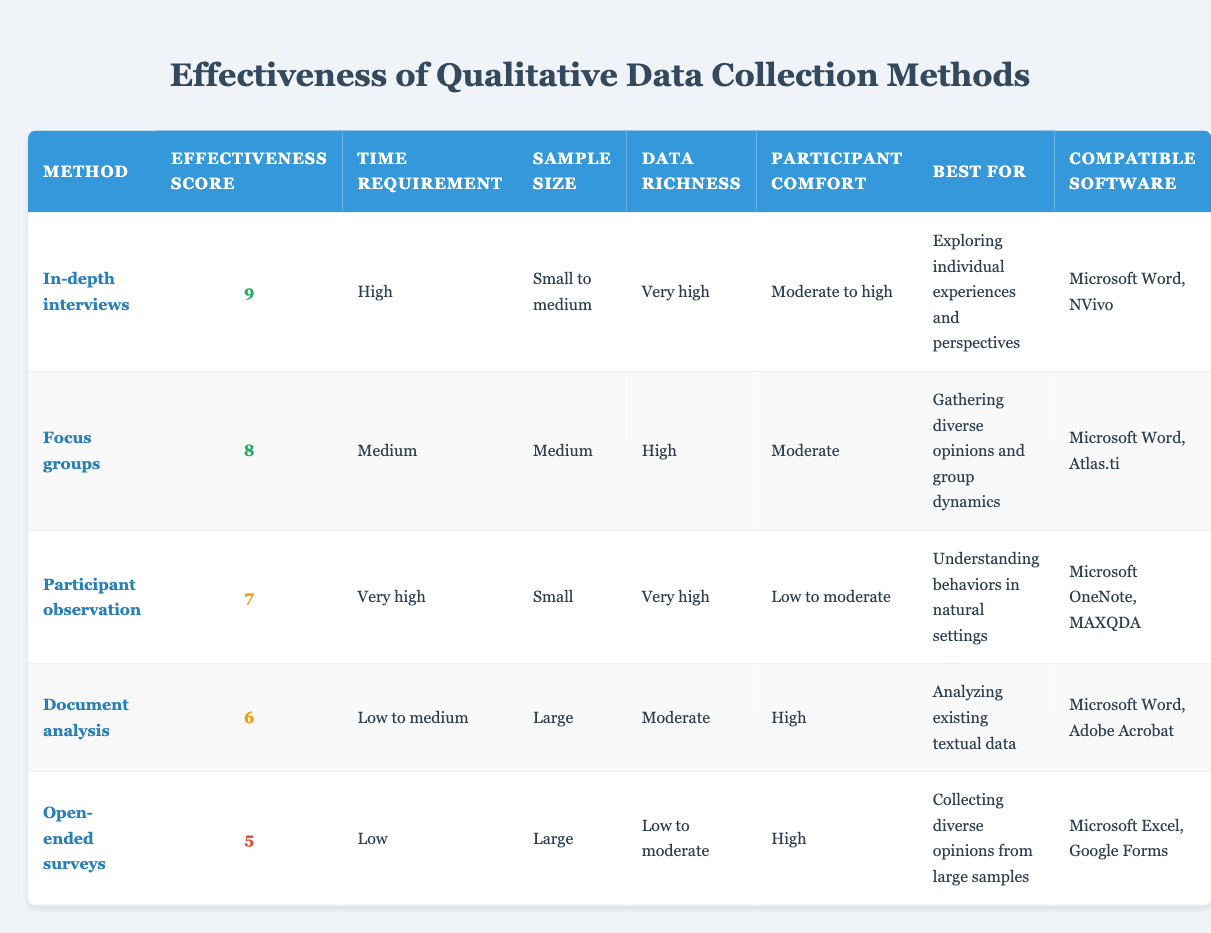What is the effectiveness score of focus groups? The effectiveness score for focus groups is given directly in the table. The value listed under the "Effectiveness Score" column for focus groups is 8.
Answer: 8 Which data collection method requires the lowest time commitment? Looking at the "Time Requirement" column, the method with the lowest requirement listed is "Document analysis" which has a time requirement classified as "Low to medium."
Answer: Document analysis Is participant observation suitable for large samples? The "Sample Size" column indicates that participant observation is classified as "Small." Since the method is designed for smaller sample sizes, it is not suitable for large samples.
Answer: No What is the average effectiveness score of the data collection methods? The effectiveness scores are 9, 8, 7, 6, and 5. To find the average, add them up: 9 + 8 + 7 + 6 + 5 = 35, then divide by 5 (the number of methods), which is 35/5 = 7.
Answer: 7 Can open-ended surveys provide very high data richness? The data richness for open-ended surveys is categorized as "Low to moderate" according to the "Data Richness" column, indicating that this method does not provide very high data richness.
Answer: No Which data collection method has the highest participant comfort? By examining the participant comfort ratings, we see that "Document analysis" has a comfort rating of "High," which is the highest compared to other methods listed.
Answer: Document analysis How many methods are suitable for exploring individual experiences and perspectives? Upon reviewing the "Best For" column, only "In-depth interviews" are specifically mentioned for exploring individual experiences and perspectives. Hence, there is only one method.
Answer: 1 Is there a method listed that uses Microsoft Excel as compatible software? Checking the "Compatible Software" column, it is evident that "Open-ended surveys" uses Microsoft Excel. Thus, this method does indeed utilize Excel.
Answer: Yes What is the combined effectiveness score of In-depth interviews and participant observation? The effectiveness scores for the two methods are 9 (In-depth interviews) and 7 (participant observation). Adding these scores together gives 9 + 7 = 16.
Answer: 16 